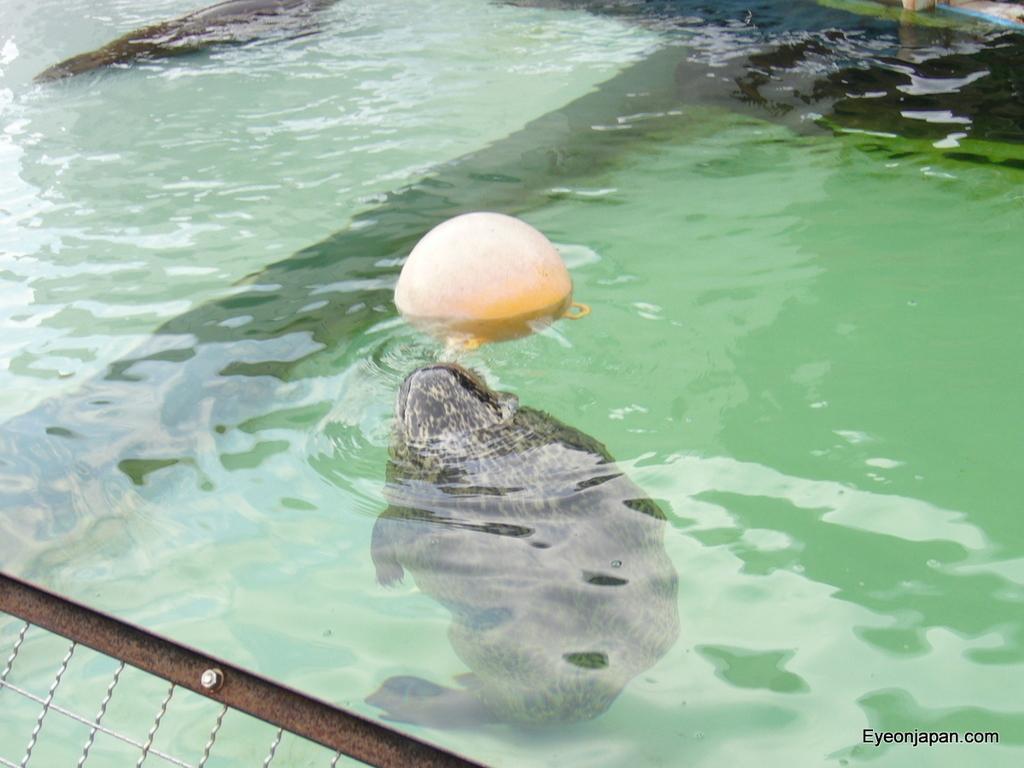Can you describe this image briefly? In this image, I can see an animal in the water and an object floating on the water. At the bottom left side of the image, It looks like a fence. At the bottom right side of the image, I can see a watermark. 